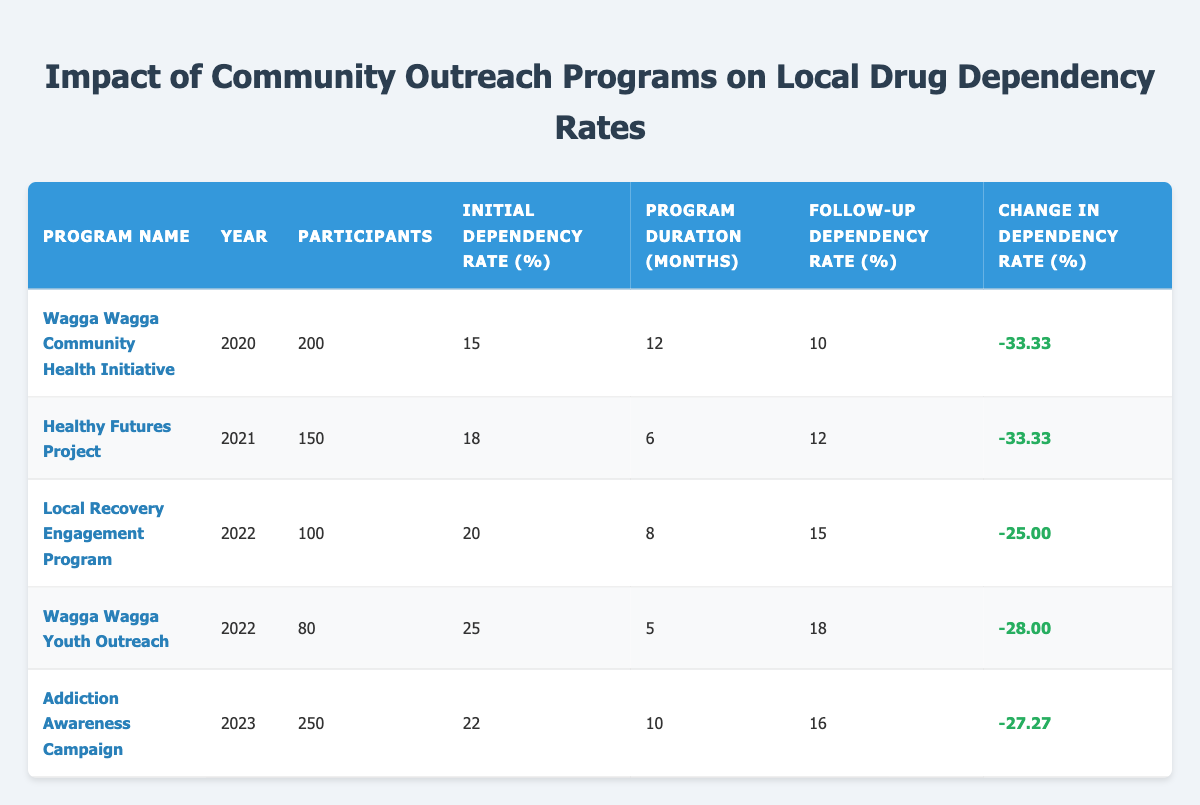What is the program with the highest number of participants? The table shows the number of participants for each outreach program. By examining the participants column, the "Addiction Awareness Campaign" has the highest number of participants at 250.
Answer: Addiction Awareness Campaign Which program had the lowest initial dependency rate? Looking at the initial dependency rate column, the "Wagga Wagga Community Health Initiative" shows an initial rate of 15, which is lower than all other programs listed.
Answer: Wagga Wagga Community Health Initiative What was the average change in dependency rate across all programs? To find the average change, sum all the percent changes (-33.33, -33.33, -25, -28, -27.27) which equals -147.93. There are 5 programs, so the average change is -147.93/5 = -29.586.
Answer: -29.59 Did any program see an increase in the dependency rate? By analyzing the follow-up dependency rates against initial rates for each program, it is observed that all programs showed a decrease in the dependency rate, so none had an increase.
Answer: No Which program had the longest duration? Reviewing the program duration column, the "Wagga Wagga Community Health Initiative" lasted for 12 months, which is longer than all others.
Answer: Wagga Wagga Community Health Initiative What is the follow-up dependency rate for the "Healthy Futures Project"? According to the table, the follow-up dependency rate for the "Healthy Futures Project" is 12.
Answer: 12 How many programs were conducted in the year 2022? By counting the entries for the year 2022, there are two programs listed: the "Local Recovery Engagement Program" and the "Wagga Wagga Youth Outreach."
Answer: 2 What is the percent change in dependency rate for the "Wagga Wagga Youth Outreach"? In the table, the percent change for the "Wagga Wagga Youth Outreach" is indicated as -28.
Answer: -28 Which program had the highest follow-up dependency rate? Examining the follow-up dependency rates across all programs, the "Wagga Wagga Youth Outreach" had the highest follow-up rate of 18.
Answer: Wagga Wagga Youth Outreach 